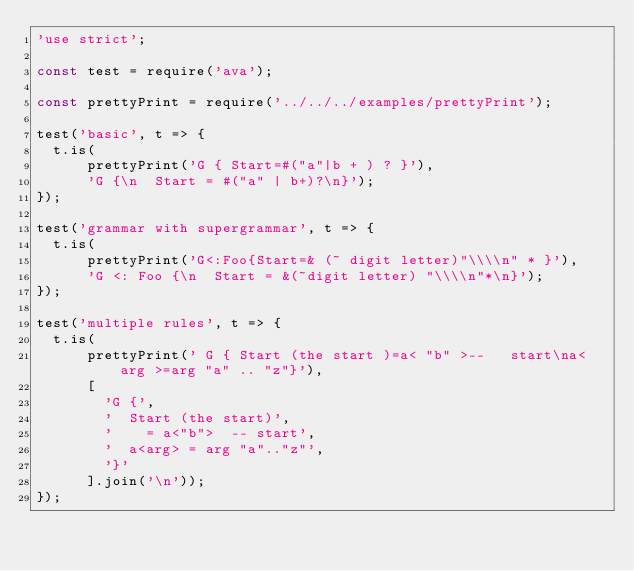Convert code to text. <code><loc_0><loc_0><loc_500><loc_500><_JavaScript_>'use strict';

const test = require('ava');

const prettyPrint = require('../../../examples/prettyPrint');

test('basic', t => {
  t.is(
      prettyPrint('G { Start=#("a"|b + ) ? }'),
      'G {\n  Start = #("a" | b+)?\n}');
});

test('grammar with supergrammar', t => {
  t.is(
      prettyPrint('G<:Foo{Start=& (~ digit letter)"\\\\n" * }'),
      'G <: Foo {\n  Start = &(~digit letter) "\\\\n"*\n}');
});

test('multiple rules', t => {
  t.is(
      prettyPrint(' G { Start (the start )=a< "b" >--   start\na< arg >=arg "a" .. "z"}'),
      [
        'G {',
        '  Start (the start)',
        '    = a<"b">  -- start',
        '  a<arg> = arg "a".."z"',
        '}'
      ].join('\n'));
});
</code> 